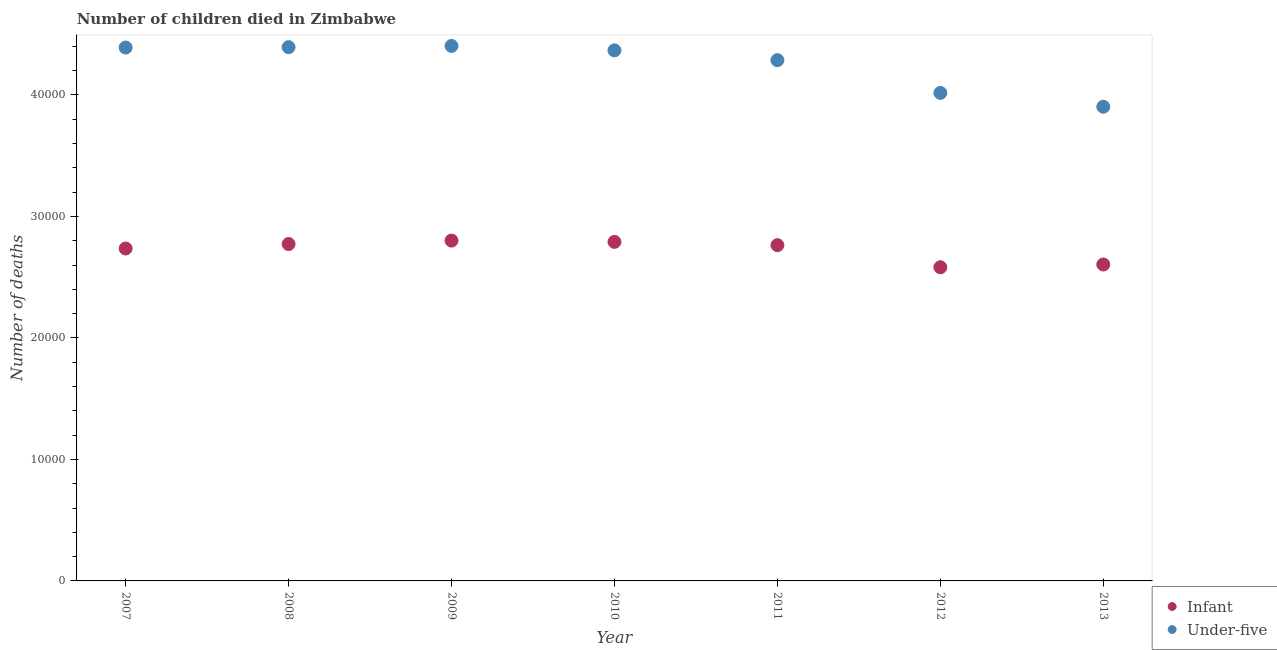How many different coloured dotlines are there?
Make the answer very short. 2. Is the number of dotlines equal to the number of legend labels?
Your response must be concise. Yes. What is the number of under-five deaths in 2008?
Make the answer very short. 4.39e+04. Across all years, what is the maximum number of infant deaths?
Offer a very short reply. 2.80e+04. Across all years, what is the minimum number of infant deaths?
Your answer should be very brief. 2.58e+04. In which year was the number of infant deaths minimum?
Offer a very short reply. 2012. What is the total number of under-five deaths in the graph?
Your answer should be compact. 2.98e+05. What is the difference between the number of infant deaths in 2009 and that in 2013?
Offer a terse response. 1966. What is the difference between the number of infant deaths in 2007 and the number of under-five deaths in 2013?
Offer a very short reply. -1.17e+04. What is the average number of infant deaths per year?
Give a very brief answer. 2.72e+04. In the year 2007, what is the difference between the number of under-five deaths and number of infant deaths?
Offer a very short reply. 1.65e+04. What is the ratio of the number of infant deaths in 2012 to that in 2013?
Make the answer very short. 0.99. Is the number of infant deaths in 2008 less than that in 2010?
Provide a short and direct response. Yes. What is the difference between the highest and the second highest number of under-five deaths?
Make the answer very short. 101. What is the difference between the highest and the lowest number of under-five deaths?
Your answer should be very brief. 5005. Is the sum of the number of under-five deaths in 2008 and 2013 greater than the maximum number of infant deaths across all years?
Provide a short and direct response. Yes. Is the number of infant deaths strictly greater than the number of under-five deaths over the years?
Provide a short and direct response. No. Is the number of under-five deaths strictly less than the number of infant deaths over the years?
Your answer should be very brief. No. What is the difference between two consecutive major ticks on the Y-axis?
Ensure brevity in your answer.  10000. Are the values on the major ticks of Y-axis written in scientific E-notation?
Your answer should be compact. No. Does the graph contain any zero values?
Provide a short and direct response. No. How many legend labels are there?
Offer a very short reply. 2. How are the legend labels stacked?
Provide a short and direct response. Vertical. What is the title of the graph?
Your answer should be very brief. Number of children died in Zimbabwe. What is the label or title of the X-axis?
Your answer should be very brief. Year. What is the label or title of the Y-axis?
Offer a very short reply. Number of deaths. What is the Number of deaths of Infant in 2007?
Give a very brief answer. 2.74e+04. What is the Number of deaths in Under-five in 2007?
Ensure brevity in your answer.  4.39e+04. What is the Number of deaths of Infant in 2008?
Give a very brief answer. 2.77e+04. What is the Number of deaths in Under-five in 2008?
Provide a succinct answer. 4.39e+04. What is the Number of deaths of Infant in 2009?
Provide a short and direct response. 2.80e+04. What is the Number of deaths in Under-five in 2009?
Give a very brief answer. 4.40e+04. What is the Number of deaths in Infant in 2010?
Keep it short and to the point. 2.79e+04. What is the Number of deaths in Under-five in 2010?
Offer a very short reply. 4.37e+04. What is the Number of deaths in Infant in 2011?
Provide a short and direct response. 2.76e+04. What is the Number of deaths of Under-five in 2011?
Ensure brevity in your answer.  4.29e+04. What is the Number of deaths of Infant in 2012?
Offer a very short reply. 2.58e+04. What is the Number of deaths of Under-five in 2012?
Provide a succinct answer. 4.02e+04. What is the Number of deaths of Infant in 2013?
Ensure brevity in your answer.  2.60e+04. What is the Number of deaths of Under-five in 2013?
Your answer should be very brief. 3.90e+04. Across all years, what is the maximum Number of deaths in Infant?
Make the answer very short. 2.80e+04. Across all years, what is the maximum Number of deaths in Under-five?
Keep it short and to the point. 4.40e+04. Across all years, what is the minimum Number of deaths of Infant?
Keep it short and to the point. 2.58e+04. Across all years, what is the minimum Number of deaths of Under-five?
Make the answer very short. 3.90e+04. What is the total Number of deaths of Infant in the graph?
Your response must be concise. 1.91e+05. What is the total Number of deaths of Under-five in the graph?
Your response must be concise. 2.98e+05. What is the difference between the Number of deaths in Infant in 2007 and that in 2008?
Ensure brevity in your answer.  -369. What is the difference between the Number of deaths of Under-five in 2007 and that in 2008?
Your answer should be very brief. -32. What is the difference between the Number of deaths in Infant in 2007 and that in 2009?
Your answer should be compact. -652. What is the difference between the Number of deaths in Under-five in 2007 and that in 2009?
Give a very brief answer. -133. What is the difference between the Number of deaths in Infant in 2007 and that in 2010?
Offer a terse response. -546. What is the difference between the Number of deaths of Under-five in 2007 and that in 2010?
Offer a very short reply. 230. What is the difference between the Number of deaths in Infant in 2007 and that in 2011?
Your answer should be very brief. -276. What is the difference between the Number of deaths in Under-five in 2007 and that in 2011?
Offer a very short reply. 1038. What is the difference between the Number of deaths in Infant in 2007 and that in 2012?
Your answer should be very brief. 1542. What is the difference between the Number of deaths of Under-five in 2007 and that in 2012?
Offer a very short reply. 3733. What is the difference between the Number of deaths in Infant in 2007 and that in 2013?
Your answer should be very brief. 1314. What is the difference between the Number of deaths in Under-five in 2007 and that in 2013?
Offer a very short reply. 4872. What is the difference between the Number of deaths of Infant in 2008 and that in 2009?
Provide a short and direct response. -283. What is the difference between the Number of deaths in Under-five in 2008 and that in 2009?
Give a very brief answer. -101. What is the difference between the Number of deaths in Infant in 2008 and that in 2010?
Your answer should be compact. -177. What is the difference between the Number of deaths in Under-five in 2008 and that in 2010?
Your response must be concise. 262. What is the difference between the Number of deaths of Infant in 2008 and that in 2011?
Offer a terse response. 93. What is the difference between the Number of deaths of Under-five in 2008 and that in 2011?
Provide a short and direct response. 1070. What is the difference between the Number of deaths in Infant in 2008 and that in 2012?
Provide a short and direct response. 1911. What is the difference between the Number of deaths of Under-five in 2008 and that in 2012?
Provide a short and direct response. 3765. What is the difference between the Number of deaths of Infant in 2008 and that in 2013?
Your answer should be compact. 1683. What is the difference between the Number of deaths of Under-five in 2008 and that in 2013?
Make the answer very short. 4904. What is the difference between the Number of deaths in Infant in 2009 and that in 2010?
Give a very brief answer. 106. What is the difference between the Number of deaths in Under-five in 2009 and that in 2010?
Provide a short and direct response. 363. What is the difference between the Number of deaths of Infant in 2009 and that in 2011?
Offer a terse response. 376. What is the difference between the Number of deaths in Under-five in 2009 and that in 2011?
Your response must be concise. 1171. What is the difference between the Number of deaths of Infant in 2009 and that in 2012?
Provide a short and direct response. 2194. What is the difference between the Number of deaths of Under-five in 2009 and that in 2012?
Your answer should be compact. 3866. What is the difference between the Number of deaths in Infant in 2009 and that in 2013?
Offer a terse response. 1966. What is the difference between the Number of deaths in Under-five in 2009 and that in 2013?
Your response must be concise. 5005. What is the difference between the Number of deaths in Infant in 2010 and that in 2011?
Offer a very short reply. 270. What is the difference between the Number of deaths in Under-five in 2010 and that in 2011?
Provide a short and direct response. 808. What is the difference between the Number of deaths of Infant in 2010 and that in 2012?
Provide a succinct answer. 2088. What is the difference between the Number of deaths of Under-five in 2010 and that in 2012?
Offer a terse response. 3503. What is the difference between the Number of deaths in Infant in 2010 and that in 2013?
Offer a very short reply. 1860. What is the difference between the Number of deaths in Under-five in 2010 and that in 2013?
Ensure brevity in your answer.  4642. What is the difference between the Number of deaths in Infant in 2011 and that in 2012?
Make the answer very short. 1818. What is the difference between the Number of deaths in Under-five in 2011 and that in 2012?
Ensure brevity in your answer.  2695. What is the difference between the Number of deaths in Infant in 2011 and that in 2013?
Your answer should be compact. 1590. What is the difference between the Number of deaths of Under-five in 2011 and that in 2013?
Offer a terse response. 3834. What is the difference between the Number of deaths of Infant in 2012 and that in 2013?
Your answer should be compact. -228. What is the difference between the Number of deaths in Under-five in 2012 and that in 2013?
Provide a short and direct response. 1139. What is the difference between the Number of deaths of Infant in 2007 and the Number of deaths of Under-five in 2008?
Your response must be concise. -1.66e+04. What is the difference between the Number of deaths of Infant in 2007 and the Number of deaths of Under-five in 2009?
Provide a short and direct response. -1.67e+04. What is the difference between the Number of deaths in Infant in 2007 and the Number of deaths in Under-five in 2010?
Your answer should be very brief. -1.63e+04. What is the difference between the Number of deaths in Infant in 2007 and the Number of deaths in Under-five in 2011?
Keep it short and to the point. -1.55e+04. What is the difference between the Number of deaths of Infant in 2007 and the Number of deaths of Under-five in 2012?
Your answer should be very brief. -1.28e+04. What is the difference between the Number of deaths of Infant in 2007 and the Number of deaths of Under-five in 2013?
Offer a very short reply. -1.17e+04. What is the difference between the Number of deaths of Infant in 2008 and the Number of deaths of Under-five in 2009?
Make the answer very short. -1.63e+04. What is the difference between the Number of deaths of Infant in 2008 and the Number of deaths of Under-five in 2010?
Make the answer very short. -1.59e+04. What is the difference between the Number of deaths in Infant in 2008 and the Number of deaths in Under-five in 2011?
Provide a succinct answer. -1.51e+04. What is the difference between the Number of deaths of Infant in 2008 and the Number of deaths of Under-five in 2012?
Offer a terse response. -1.24e+04. What is the difference between the Number of deaths in Infant in 2008 and the Number of deaths in Under-five in 2013?
Your response must be concise. -1.13e+04. What is the difference between the Number of deaths in Infant in 2009 and the Number of deaths in Under-five in 2010?
Provide a short and direct response. -1.57e+04. What is the difference between the Number of deaths of Infant in 2009 and the Number of deaths of Under-five in 2011?
Keep it short and to the point. -1.49e+04. What is the difference between the Number of deaths in Infant in 2009 and the Number of deaths in Under-five in 2012?
Keep it short and to the point. -1.22e+04. What is the difference between the Number of deaths of Infant in 2009 and the Number of deaths of Under-five in 2013?
Make the answer very short. -1.10e+04. What is the difference between the Number of deaths in Infant in 2010 and the Number of deaths in Under-five in 2011?
Provide a short and direct response. -1.50e+04. What is the difference between the Number of deaths of Infant in 2010 and the Number of deaths of Under-five in 2012?
Your answer should be very brief. -1.23e+04. What is the difference between the Number of deaths in Infant in 2010 and the Number of deaths in Under-five in 2013?
Provide a succinct answer. -1.11e+04. What is the difference between the Number of deaths of Infant in 2011 and the Number of deaths of Under-five in 2012?
Keep it short and to the point. -1.25e+04. What is the difference between the Number of deaths of Infant in 2011 and the Number of deaths of Under-five in 2013?
Your answer should be very brief. -1.14e+04. What is the difference between the Number of deaths of Infant in 2012 and the Number of deaths of Under-five in 2013?
Your response must be concise. -1.32e+04. What is the average Number of deaths in Infant per year?
Keep it short and to the point. 2.72e+04. What is the average Number of deaths of Under-five per year?
Ensure brevity in your answer.  4.25e+04. In the year 2007, what is the difference between the Number of deaths in Infant and Number of deaths in Under-five?
Ensure brevity in your answer.  -1.65e+04. In the year 2008, what is the difference between the Number of deaths in Infant and Number of deaths in Under-five?
Provide a succinct answer. -1.62e+04. In the year 2009, what is the difference between the Number of deaths in Infant and Number of deaths in Under-five?
Offer a terse response. -1.60e+04. In the year 2010, what is the difference between the Number of deaths of Infant and Number of deaths of Under-five?
Offer a terse response. -1.58e+04. In the year 2011, what is the difference between the Number of deaths in Infant and Number of deaths in Under-five?
Keep it short and to the point. -1.52e+04. In the year 2012, what is the difference between the Number of deaths of Infant and Number of deaths of Under-five?
Ensure brevity in your answer.  -1.44e+04. In the year 2013, what is the difference between the Number of deaths of Infant and Number of deaths of Under-five?
Make the answer very short. -1.30e+04. What is the ratio of the Number of deaths in Infant in 2007 to that in 2008?
Provide a short and direct response. 0.99. What is the ratio of the Number of deaths of Infant in 2007 to that in 2009?
Your answer should be very brief. 0.98. What is the ratio of the Number of deaths of Under-five in 2007 to that in 2009?
Make the answer very short. 1. What is the ratio of the Number of deaths of Infant in 2007 to that in 2010?
Ensure brevity in your answer.  0.98. What is the ratio of the Number of deaths of Infant in 2007 to that in 2011?
Offer a terse response. 0.99. What is the ratio of the Number of deaths in Under-five in 2007 to that in 2011?
Offer a very short reply. 1.02. What is the ratio of the Number of deaths of Infant in 2007 to that in 2012?
Make the answer very short. 1.06. What is the ratio of the Number of deaths of Under-five in 2007 to that in 2012?
Provide a short and direct response. 1.09. What is the ratio of the Number of deaths of Infant in 2007 to that in 2013?
Your response must be concise. 1.05. What is the ratio of the Number of deaths of Under-five in 2007 to that in 2013?
Your answer should be compact. 1.12. What is the ratio of the Number of deaths of Under-five in 2008 to that in 2009?
Give a very brief answer. 1. What is the ratio of the Number of deaths of Infant in 2008 to that in 2010?
Your answer should be compact. 0.99. What is the ratio of the Number of deaths of Under-five in 2008 to that in 2010?
Provide a succinct answer. 1.01. What is the ratio of the Number of deaths of Under-five in 2008 to that in 2011?
Your answer should be compact. 1.02. What is the ratio of the Number of deaths in Infant in 2008 to that in 2012?
Your answer should be very brief. 1.07. What is the ratio of the Number of deaths in Under-five in 2008 to that in 2012?
Your response must be concise. 1.09. What is the ratio of the Number of deaths in Infant in 2008 to that in 2013?
Give a very brief answer. 1.06. What is the ratio of the Number of deaths of Under-five in 2008 to that in 2013?
Provide a short and direct response. 1.13. What is the ratio of the Number of deaths of Under-five in 2009 to that in 2010?
Provide a short and direct response. 1.01. What is the ratio of the Number of deaths in Infant in 2009 to that in 2011?
Your answer should be compact. 1.01. What is the ratio of the Number of deaths in Under-five in 2009 to that in 2011?
Offer a terse response. 1.03. What is the ratio of the Number of deaths of Infant in 2009 to that in 2012?
Give a very brief answer. 1.08. What is the ratio of the Number of deaths in Under-five in 2009 to that in 2012?
Keep it short and to the point. 1.1. What is the ratio of the Number of deaths in Infant in 2009 to that in 2013?
Your answer should be very brief. 1.08. What is the ratio of the Number of deaths of Under-five in 2009 to that in 2013?
Offer a very short reply. 1.13. What is the ratio of the Number of deaths in Infant in 2010 to that in 2011?
Your answer should be very brief. 1.01. What is the ratio of the Number of deaths of Under-five in 2010 to that in 2011?
Your response must be concise. 1.02. What is the ratio of the Number of deaths in Infant in 2010 to that in 2012?
Provide a short and direct response. 1.08. What is the ratio of the Number of deaths of Under-five in 2010 to that in 2012?
Make the answer very short. 1.09. What is the ratio of the Number of deaths of Infant in 2010 to that in 2013?
Ensure brevity in your answer.  1.07. What is the ratio of the Number of deaths of Under-five in 2010 to that in 2013?
Offer a very short reply. 1.12. What is the ratio of the Number of deaths in Infant in 2011 to that in 2012?
Make the answer very short. 1.07. What is the ratio of the Number of deaths of Under-five in 2011 to that in 2012?
Keep it short and to the point. 1.07. What is the ratio of the Number of deaths in Infant in 2011 to that in 2013?
Make the answer very short. 1.06. What is the ratio of the Number of deaths of Under-five in 2011 to that in 2013?
Make the answer very short. 1.1. What is the ratio of the Number of deaths in Infant in 2012 to that in 2013?
Provide a succinct answer. 0.99. What is the ratio of the Number of deaths of Under-five in 2012 to that in 2013?
Give a very brief answer. 1.03. What is the difference between the highest and the second highest Number of deaths of Infant?
Keep it short and to the point. 106. What is the difference between the highest and the second highest Number of deaths of Under-five?
Ensure brevity in your answer.  101. What is the difference between the highest and the lowest Number of deaths of Infant?
Offer a terse response. 2194. What is the difference between the highest and the lowest Number of deaths of Under-five?
Your response must be concise. 5005. 